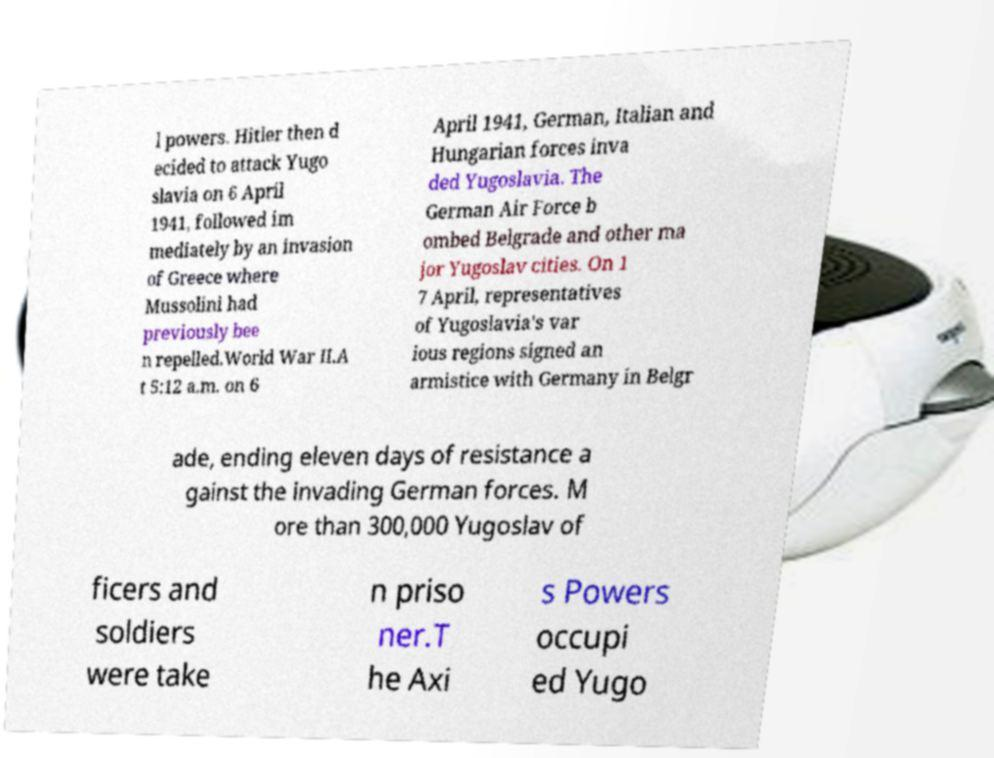Please read and relay the text visible in this image. What does it say? l powers. Hitler then d ecided to attack Yugo slavia on 6 April 1941, followed im mediately by an invasion of Greece where Mussolini had previously bee n repelled.World War II.A t 5:12 a.m. on 6 April 1941, German, Italian and Hungarian forces inva ded Yugoslavia. The German Air Force b ombed Belgrade and other ma jor Yugoslav cities. On 1 7 April, representatives of Yugoslavia's var ious regions signed an armistice with Germany in Belgr ade, ending eleven days of resistance a gainst the invading German forces. M ore than 300,000 Yugoslav of ficers and soldiers were take n priso ner.T he Axi s Powers occupi ed Yugo 